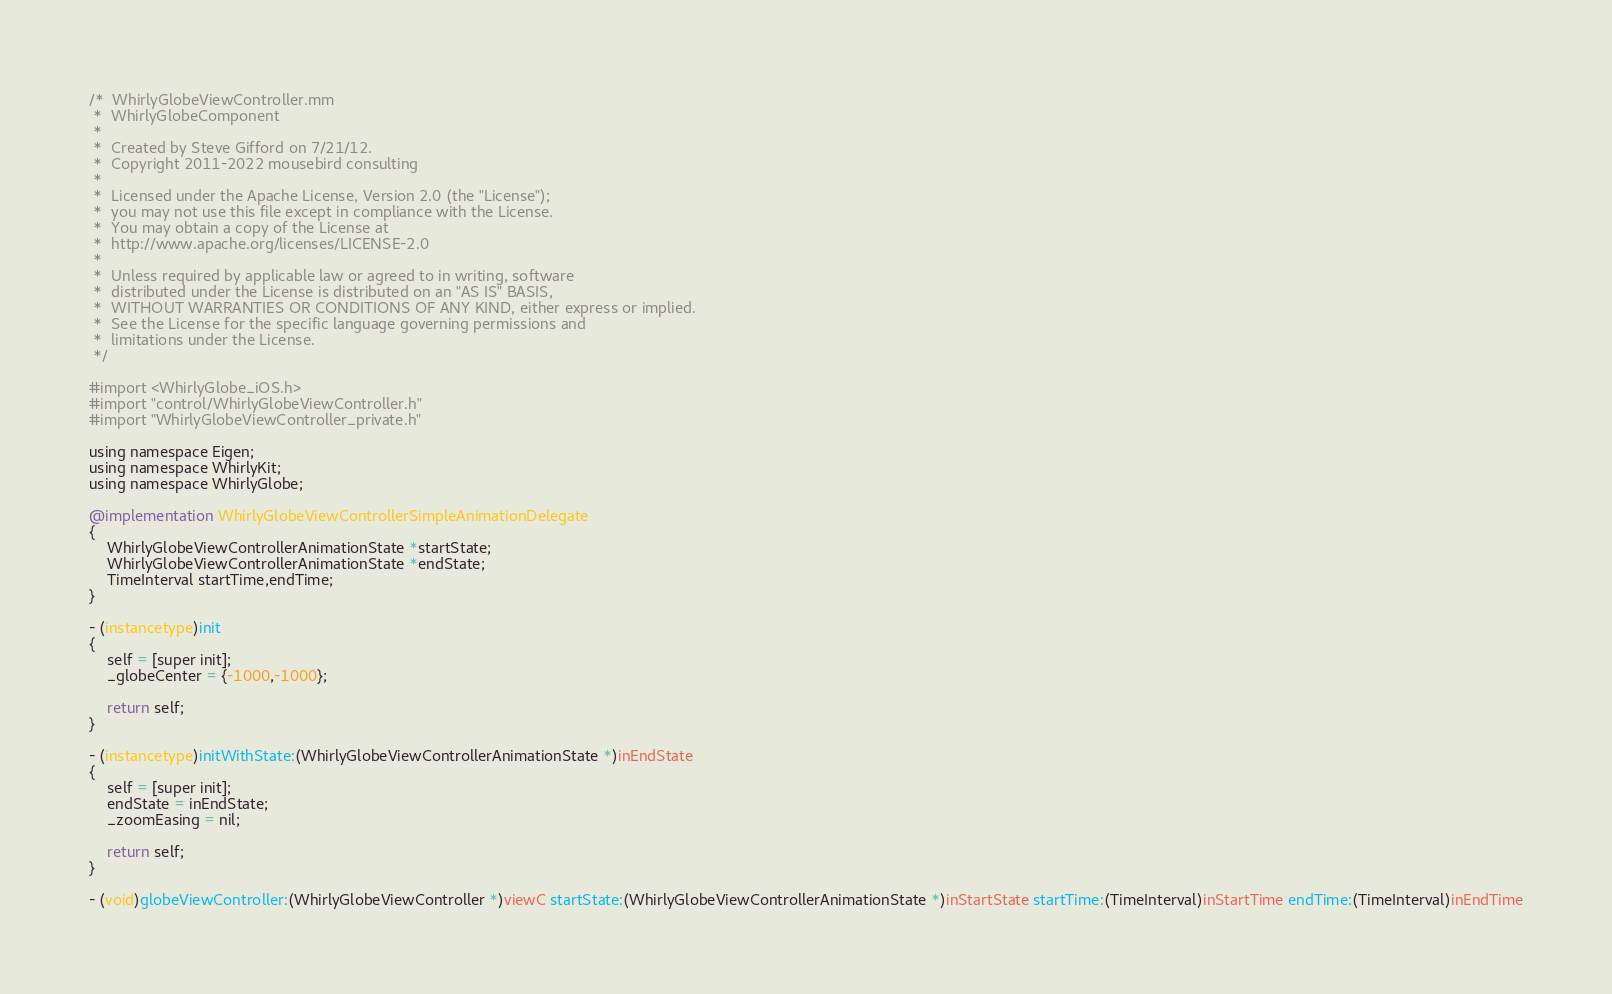Convert code to text. <code><loc_0><loc_0><loc_500><loc_500><_ObjectiveC_>/*  WhirlyGlobeViewController.mm
 *  WhirlyGlobeComponent
 *
 *  Created by Steve Gifford on 7/21/12.
 *  Copyright 2011-2022 mousebird consulting
 *
 *  Licensed under the Apache License, Version 2.0 (the "License");
 *  you may not use this file except in compliance with the License.
 *  You may obtain a copy of the License at
 *  http://www.apache.org/licenses/LICENSE-2.0
 *
 *  Unless required by applicable law or agreed to in writing, software
 *  distributed under the License is distributed on an "AS IS" BASIS,
 *  WITHOUT WARRANTIES OR CONDITIONS OF ANY KIND, either express or implied.
 *  See the License for the specific language governing permissions and
 *  limitations under the License.
 */

#import <WhirlyGlobe_iOS.h>
#import "control/WhirlyGlobeViewController.h"
#import "WhirlyGlobeViewController_private.h"

using namespace Eigen;
using namespace WhirlyKit;
using namespace WhirlyGlobe;

@implementation WhirlyGlobeViewControllerSimpleAnimationDelegate
{
    WhirlyGlobeViewControllerAnimationState *startState;
    WhirlyGlobeViewControllerAnimationState *endState;
    TimeInterval startTime,endTime;
}

- (instancetype)init
{
    self = [super init];
    _globeCenter = {-1000,-1000};
    
    return self;
}

- (instancetype)initWithState:(WhirlyGlobeViewControllerAnimationState *)inEndState
{
    self = [super init];
    endState = inEndState;
    _zoomEasing = nil;

    return self;
}

- (void)globeViewController:(WhirlyGlobeViewController *)viewC startState:(WhirlyGlobeViewControllerAnimationState *)inStartState startTime:(TimeInterval)inStartTime endTime:(TimeInterval)inEndTime</code> 